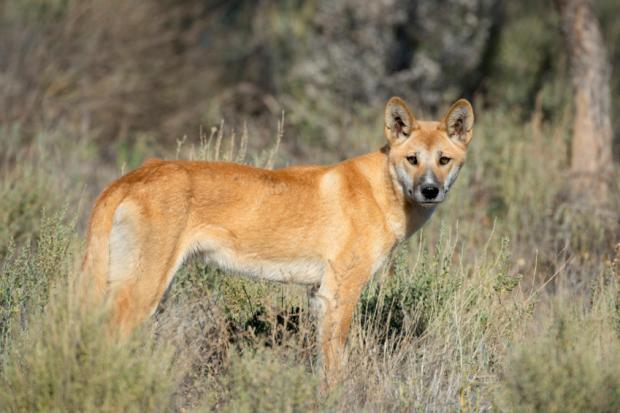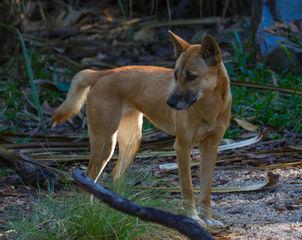The first image is the image on the left, the second image is the image on the right. Assess this claim about the two images: "The fox in the image on the left is standing in a barren sandy area.". Correct or not? Answer yes or no. No. The first image is the image on the left, the second image is the image on the right. Evaluate the accuracy of this statement regarding the images: "There is only one dog in each picture.". Is it true? Answer yes or no. Yes. 